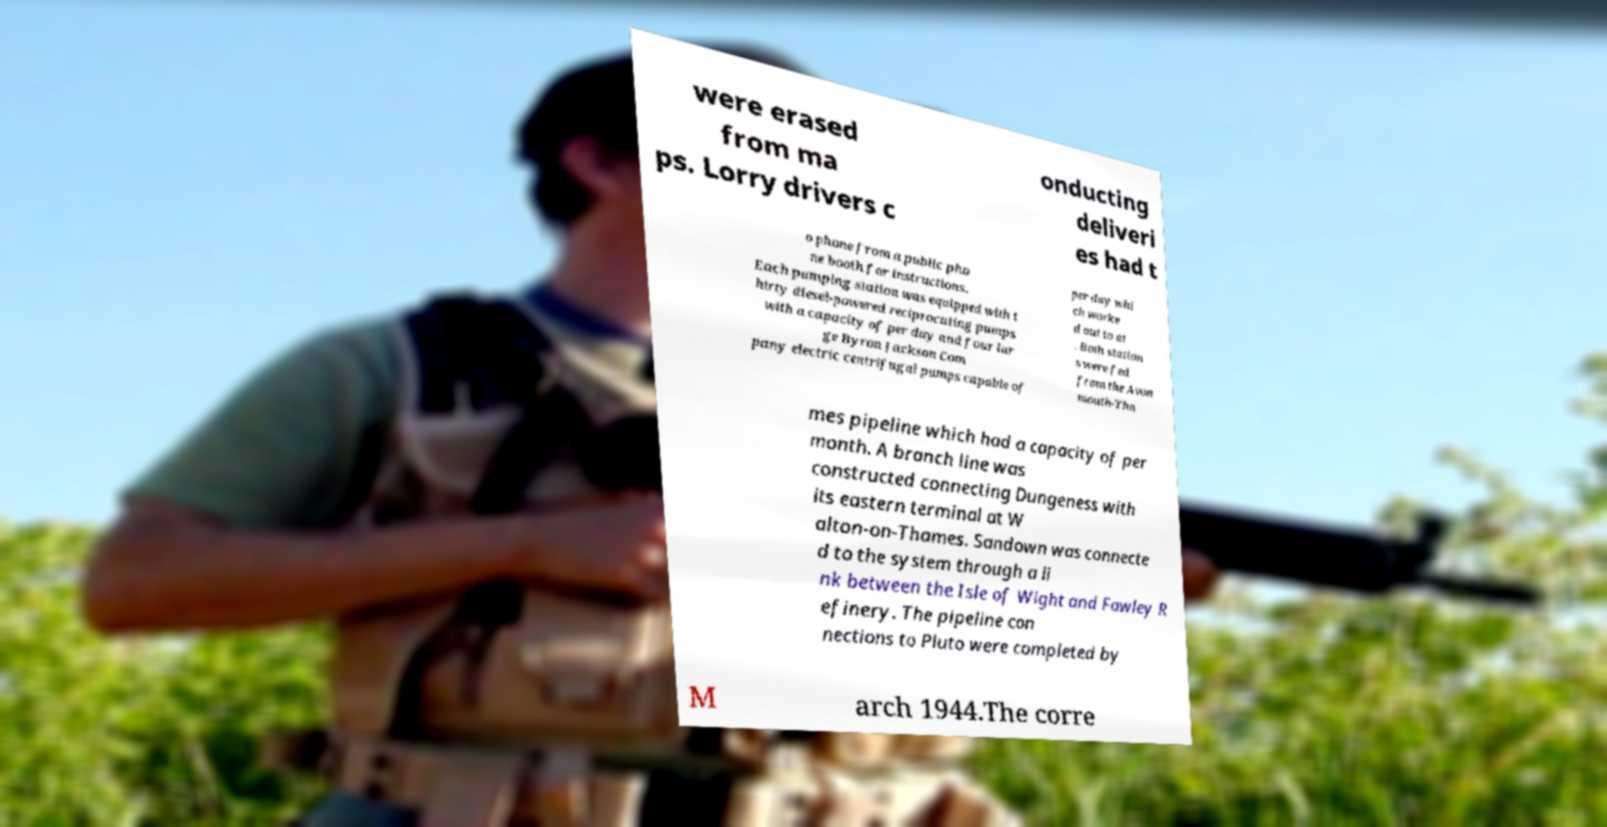Can you accurately transcribe the text from the provided image for me? were erased from ma ps. Lorry drivers c onducting deliveri es had t o phone from a public pho ne booth for instructions. Each pumping station was equipped with t hirty diesel-powered reciprocating pumps with a capacity of per day and four lar ge Byron Jackson Com pany electric centrifugal pumps capable of per day whi ch worke d out to at . Both station s were fed from the Avon mouth-Tha mes pipeline which had a capacity of per month. A branch line was constructed connecting Dungeness with its eastern terminal at W alton-on-Thames. Sandown was connecte d to the system through a li nk between the Isle of Wight and Fawley R efinery. The pipeline con nections to Pluto were completed by M arch 1944.The corre 